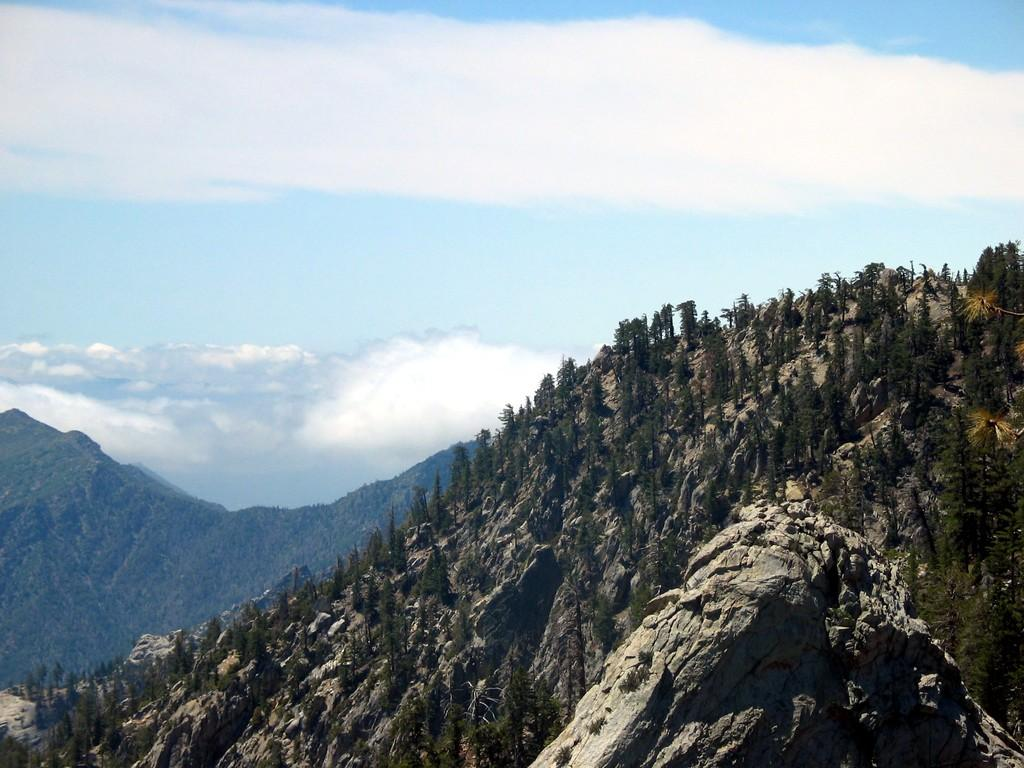What type of vegetation can be seen in the image? There are trees in the image. What geographical features are present in the image? There are hills in the image. What is visible in the background of the image? The sky is visible in the background of the image. What can be seen in the sky in the image? Clouds are present in the sky. Where is the hydrant located in the image? There is no hydrant present in the image. What type of honey can be seen dripping from the trees in the image? There is no honey present in the image; it features trees and hills. How many chickens are visible on the hills in the image? There are no chickens present in the image; it only shows trees, hills, and the sky. 